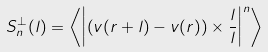Convert formula to latex. <formula><loc_0><loc_0><loc_500><loc_500>S _ { n } ^ { \perp } ( l ) = \left < \left | \left ( { v } ( { r } + { l } ) - { v } ( { r } ) \right ) \times \frac { l } { l } \right | ^ { n } \right ></formula> 